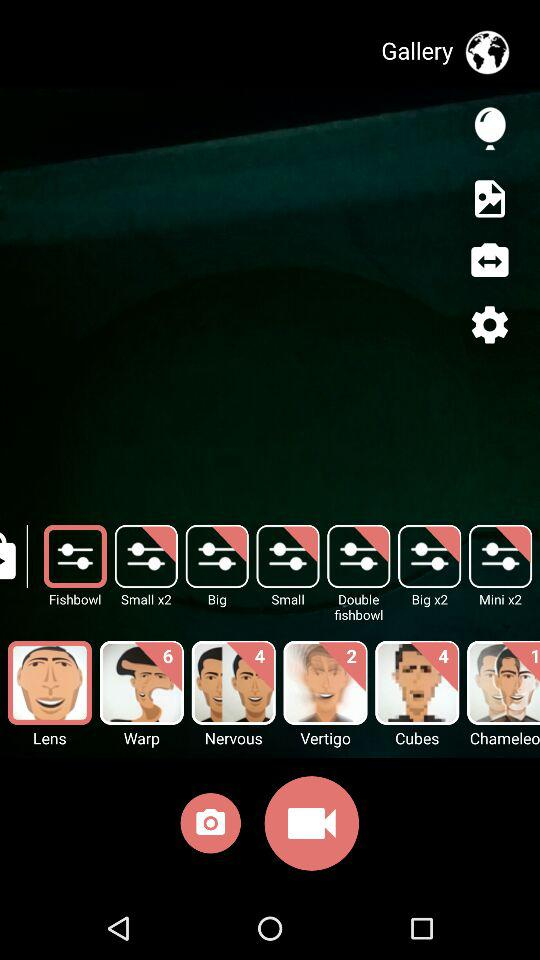How many new features are given in "Nervous"? There are 4 new features. 